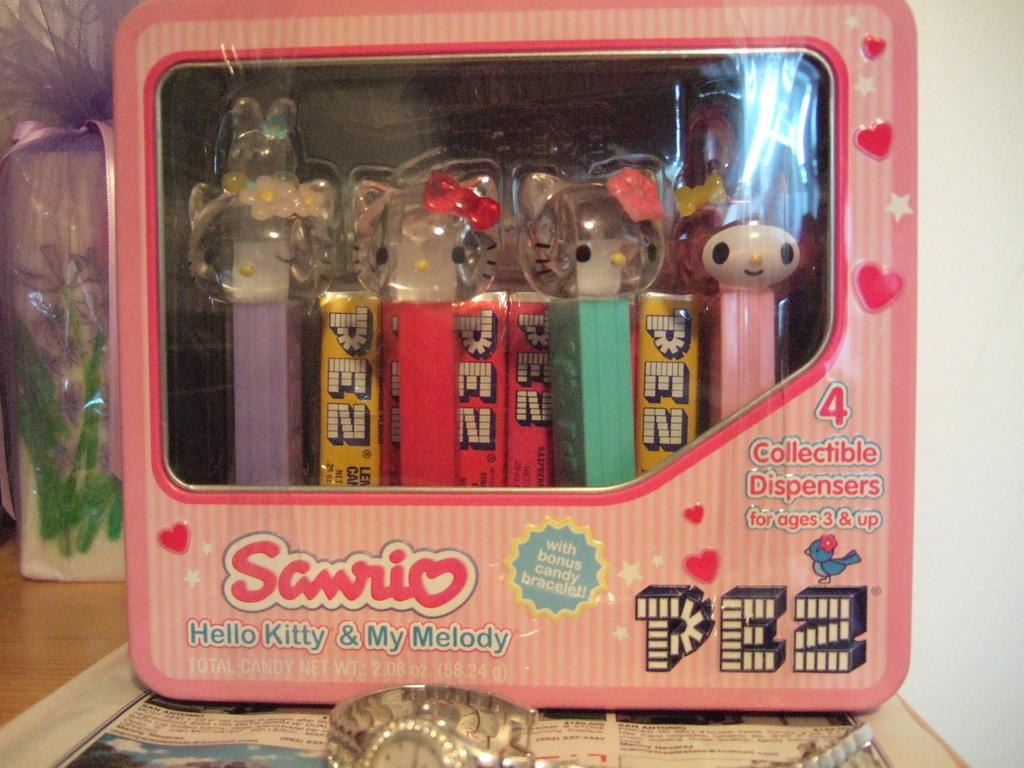What type of pens are featured in the image? There is a collection of Hello Kitty pens in the image. How are the pens stored or organized? The pens are kept inside a box. Where is the box with the pens located? The box is placed on a table. What other items can be seen on the table beside the box? There is a watch and a flower vase beside the box on the table. What type of lizards can be seen crawling on the pens in the image? There are no lizards present in the image; it features a collection of Hello Kitty pens inside a box on a table. What sound can be heard in the image due to thunder? There is no mention of thunder or any sound in the image; it only shows a box of Hello Kitty pens, a watch, and a flower vase on a table. 